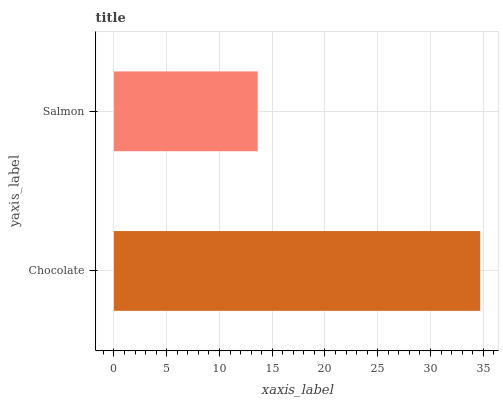Is Salmon the minimum?
Answer yes or no. Yes. Is Chocolate the maximum?
Answer yes or no. Yes. Is Salmon the maximum?
Answer yes or no. No. Is Chocolate greater than Salmon?
Answer yes or no. Yes. Is Salmon less than Chocolate?
Answer yes or no. Yes. Is Salmon greater than Chocolate?
Answer yes or no. No. Is Chocolate less than Salmon?
Answer yes or no. No. Is Chocolate the high median?
Answer yes or no. Yes. Is Salmon the low median?
Answer yes or no. Yes. Is Salmon the high median?
Answer yes or no. No. Is Chocolate the low median?
Answer yes or no. No. 